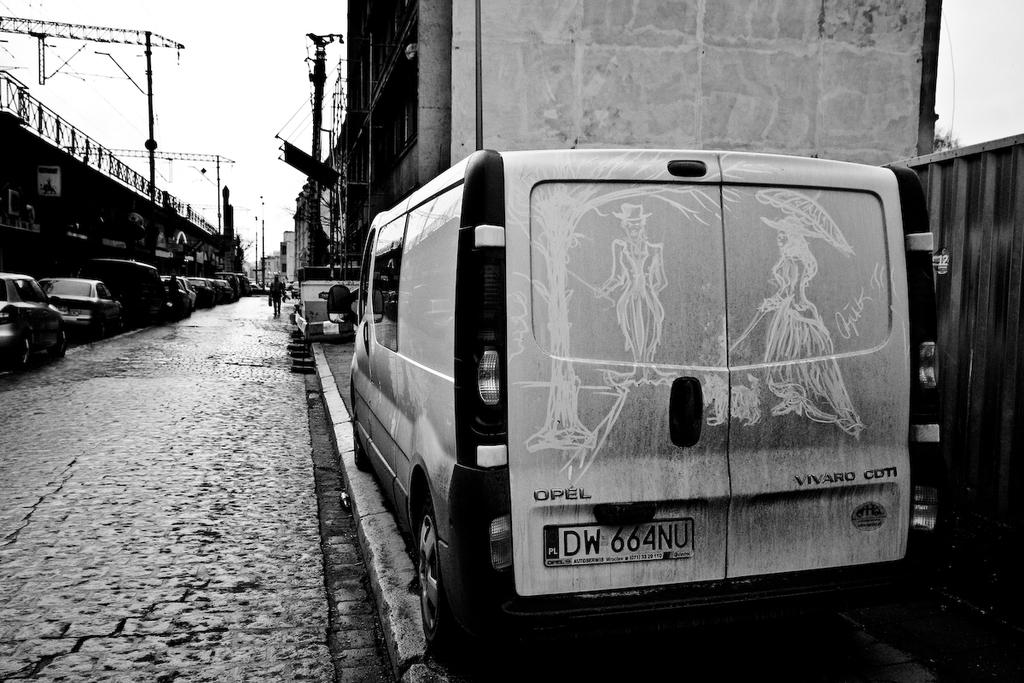What can be seen on the road in the image? There are vehicles on the road in the image. Are there any people on the road in the image? Yes, there is a person on the road in the image. What structures can be seen in the image? There are buildings visible in the image. What else can be seen in the image besides vehicles, people, and buildings? There are poles in the image. What is visible in the background of the image? The sky is visible in the background of the image. Can you tell me how many times the person on the road sneezes in the image? There is no indication of the person sneezing in the image. What type of shop can be seen in the image? There is no shop present in the image. 